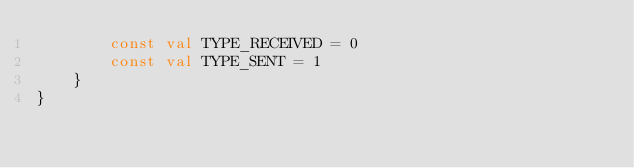Convert code to text. <code><loc_0><loc_0><loc_500><loc_500><_Kotlin_>        const val TYPE_RECEIVED = 0
        const val TYPE_SENT = 1
    }
}</code> 